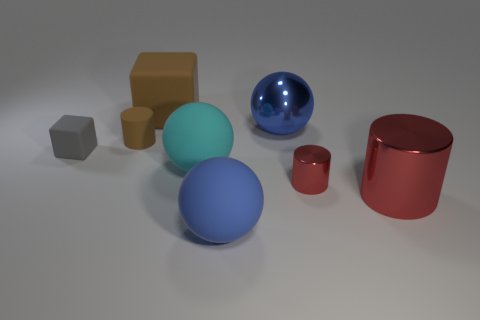Are there an equal number of gray matte blocks that are on the right side of the blue metal object and tiny shiny things that are in front of the gray cube?
Provide a short and direct response. No. What is the color of the rubber cylinder that is the same size as the gray rubber object?
Your answer should be compact. Brown. Is there a thing that has the same color as the tiny metallic cylinder?
Offer a very short reply. Yes. What number of objects are either big metal things that are right of the big metallic sphere or small gray metal objects?
Ensure brevity in your answer.  1. What number of other objects are there of the same size as the metallic ball?
Provide a short and direct response. 4. There is a tiny block that is behind the red metal thing that is left of the large metallic thing that is in front of the cyan ball; what is its material?
Ensure brevity in your answer.  Rubber. What number of cylinders are blue matte things or small gray rubber things?
Make the answer very short. 0. Are there any other things that are the same shape as the small brown rubber thing?
Keep it short and to the point. Yes. Is the number of tiny objects to the left of the large brown cube greater than the number of large blue rubber balls that are behind the big blue matte thing?
Your answer should be very brief. Yes. There is a big matte object behind the tiny cube; how many gray matte things are behind it?
Ensure brevity in your answer.  0. 